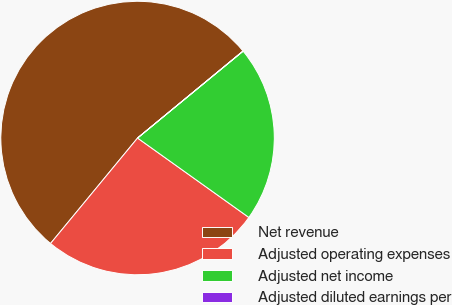<chart> <loc_0><loc_0><loc_500><loc_500><pie_chart><fcel>Net revenue<fcel>Adjusted operating expenses<fcel>Adjusted net income<fcel>Adjusted diluted earnings per<nl><fcel>53.04%<fcel>26.12%<fcel>20.82%<fcel>0.02%<nl></chart> 